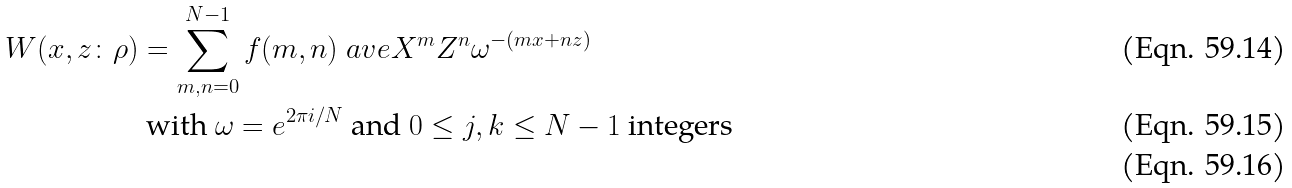Convert formula to latex. <formula><loc_0><loc_0><loc_500><loc_500>W ( x , z \colon \rho ) & = \sum _ { m , n = 0 } ^ { N - 1 } f ( m , n ) \ a v e { X ^ { m } Z ^ { n } } \omega ^ { - ( m x + n z ) } \\ & \text { with } \omega = e ^ { 2 \pi i / N } \text { and } 0 \leq j , k \leq N - 1 \text { integers } \\</formula> 